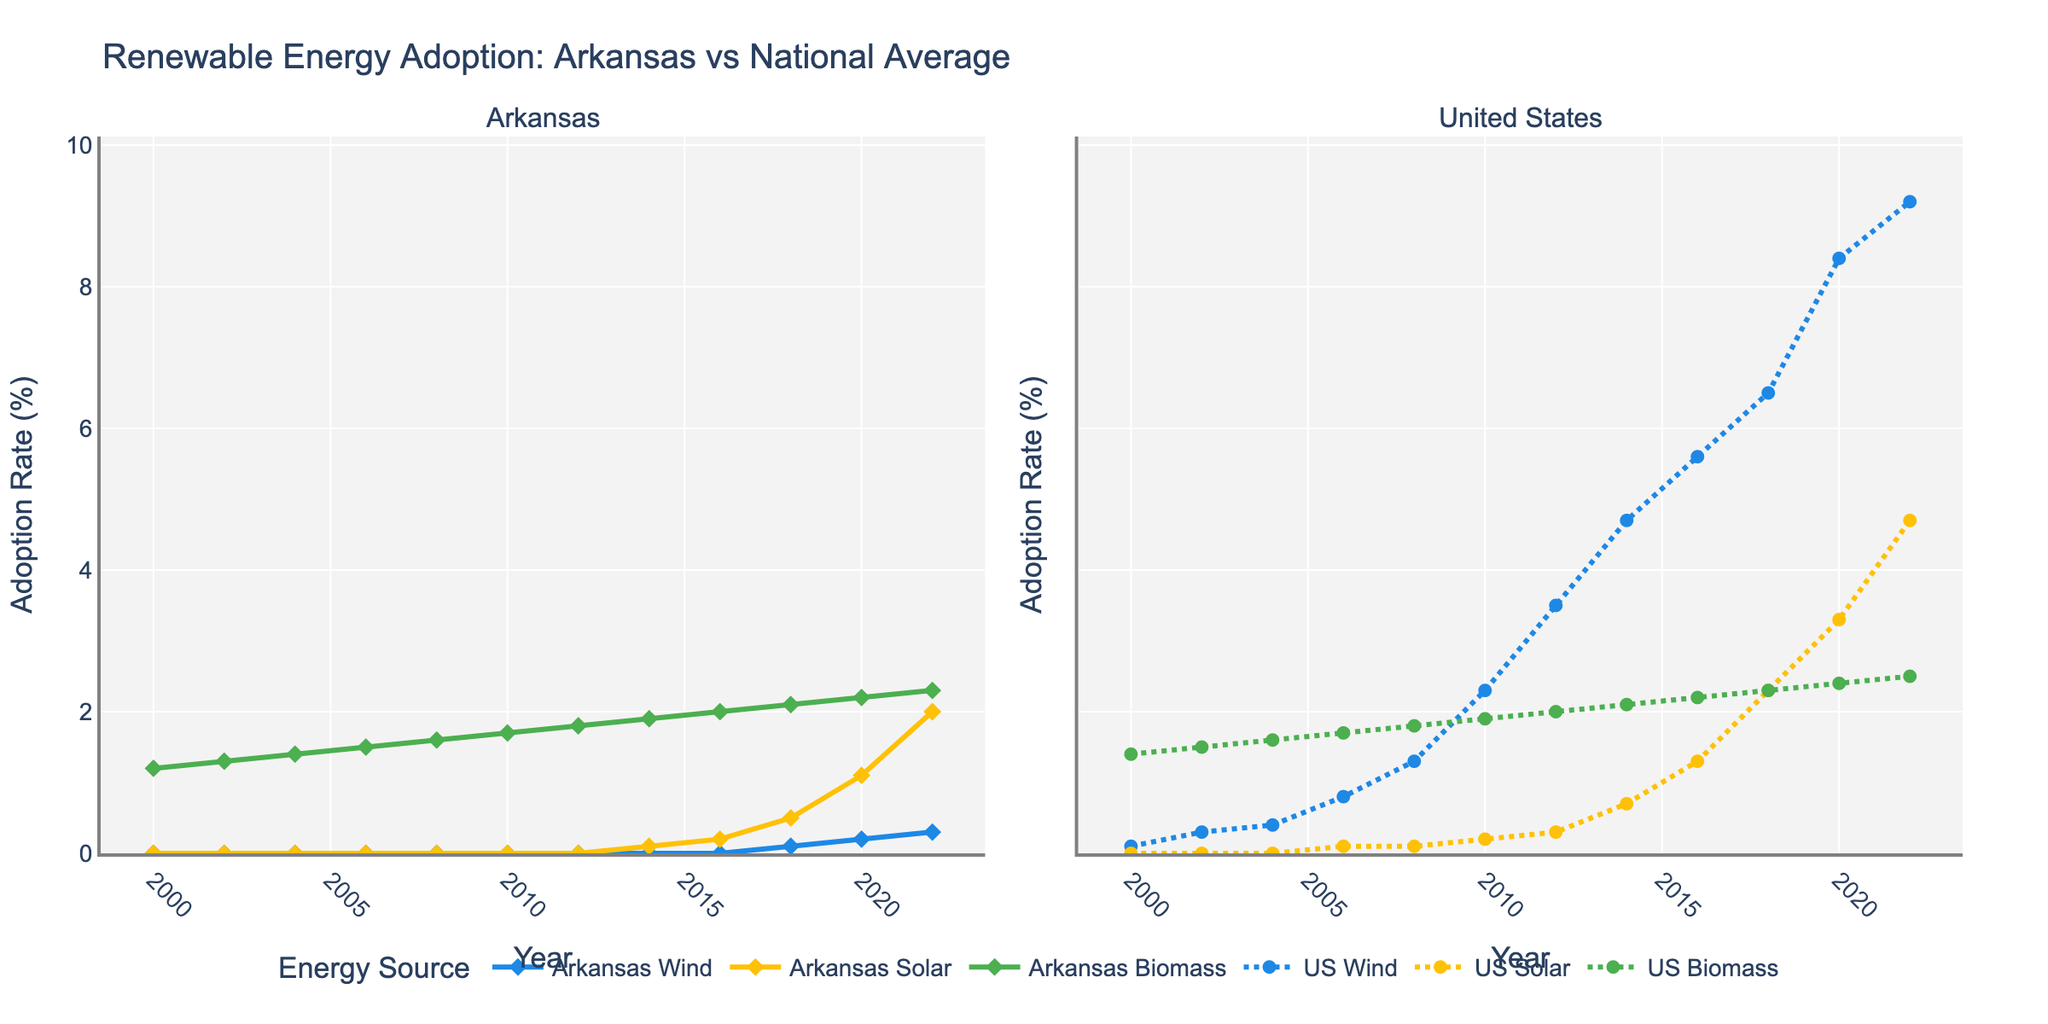What year did Arkansas first surpass 1% adoption in any renewable energy source? The figure shows lines for Arkansas Wind, Solar, and Biomass. The first instance where any of these surpass 1% is in Solar energy in 2016.
Answer: 2016 During which year did the adoption rate of Wind in the US first exceed the adoption rate of Biomass in Arkansas? By inspecting the US Wind line and comparing it to the Arkansas Biomass line, we see that US Wind adoption rate surpasses Arkansas Biomass adoption rate in 2008.
Answer: 2008 Which renewable energy source saw a steeper increase in adoption in Arkansas from 2016 to 2022: Solar or Wind? The Solar adoption rate in Arkansas increased from 0.2% in 2016 to 2.0% in 2022, while Wind increased from 0.0% to 0.3%. Solar had a steeper increase.
Answer: Solar How did the adoption rate of US Solar in 2020 compare to the adoption rate of US Biomass in 2022? We observe that US Solar adoption in 2020 was 3.3%, whereas US Biomass adoption in 2022 was 2.5%. To find the difference, subtract 2.5% from 3.3%.
Answer: 0.8% Between 2000 and 2022, which year had the greatest difference in adoption rates for Wind energy between Arkansas and the US? By comparing the lines for Arkansas Wind and US Wind over the years, the largest difference appears in 2022 with US at 9.2% and Arkansas at 0.3%, a difference of 8.9%.
Answer: 2022 How does the 2022 adoption rate of Solar energy in Arkansas compare to the national average adoption rate from 2000 to 2008? The adoption rate for Arkansas Solar in 2022 is 2.0%. The national average from 2000 to 2008 is calculated using the 2002, 2004, 2006, 2008 figures: (0.0+0.0+0.1+0.1)/4 = 0.05%. Arkansas Solar in 2022 is higher.
Answer: Higher In which year did the adoption rate of US Wind surpass 5%? The US Wind line shows that the adoption rate surpasses 5% in 2014.
Answer: 2014 Which year had the smallest difference in Biomass adoption rates between Arkansas and the US? By examining the lines for Arkansas Biomass and US Biomass, the smallest difference appears in 2000, where Arkansas is at 1.2% and the US is at 1.4%, a difference of 0.2%.
Answer: 2000 What is the overall trend of solar energy adoption in Arkansas from 2010 to 2022? From 2010 onwards, the Solar adoption rate in Arkansas shows a consistent increase from 0.0% in 2010 to 2.0% in 2022.
Answer: Increasing What is the average adoption rate of Biomass in the US over the given years? Sum the Biomass adoption rates for the US from 2000 to 2022, which are: 1.4, 1.5, 1.6, 1.7, 1.8, 1.9, 2.0, 2.1, 2.2, 2.3, 2.4, and 2.5. The sum is 24.4. Divide by the number of years (12), giving an average of 24.4/12 = 2.033%.
Answer: 2.033% 